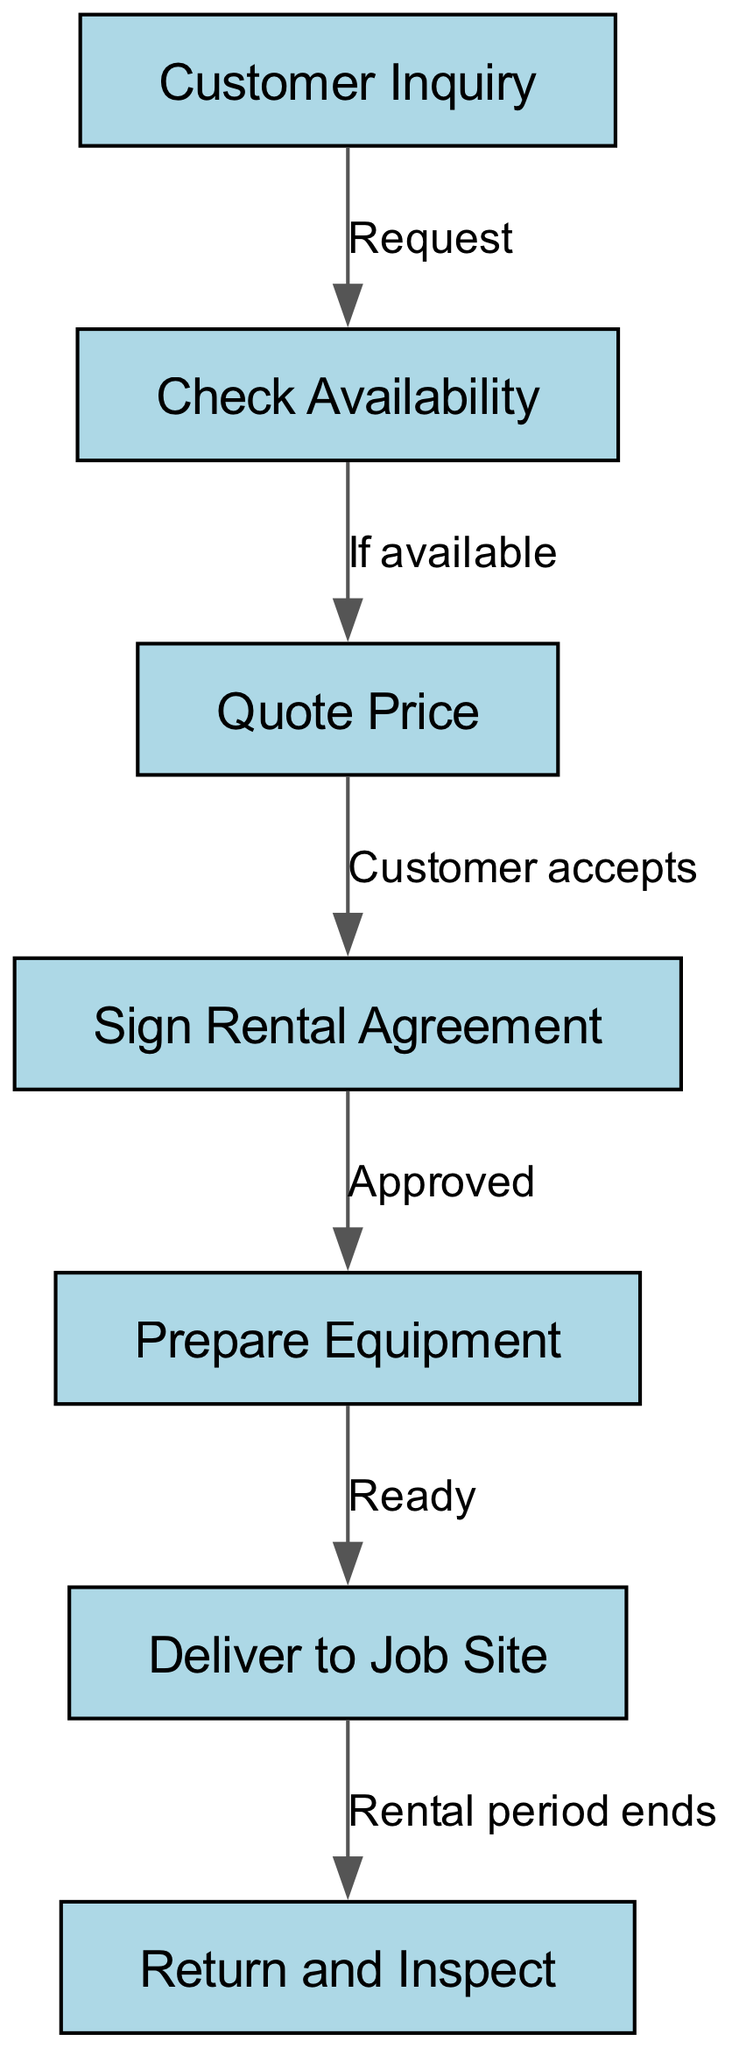What is the first step in the workflow? The diagram starts with the node labeled "Customer Inquiry," which is the first action taken when a customer wants to rent machinery.
Answer: Customer Inquiry How many nodes are in the diagram? The diagram contains a total of 7 distinct nodes, each representing a different step in the rental process.
Answer: 7 What is the connection between 'Check Availability' and 'Quote Price'? The connection shows that if the machinery is available for rent after checking, the next step is to quote the price to the customer.
Answer: If available What happens after the customer signs the rental agreement? Immediately after signing the rental agreement, the next step is to prepare the equipment for the customer’s rental.
Answer: Prepare Equipment What is the last step in the workflow? The last step in the workflow is 'Return and Inspect', which occurs at the end of the rental period.
Answer: Return and Inspect What is required for moving from 'Quote Price' to 'Sign Rental Agreement'? The customer must accept the quote price for the process to move forward towards signing the rental agreement.
Answer: Customer accepts What needs to happen before delivering to the job site? Preparation of the equipment must be completed before delivery can take place.
Answer: Ready Which step comes directly after 'Deliver to Job Site'? The step that follows delivering to the job site is 'Return and Inspect', which indicates the phase of equipment return after the rental period concludes.
Answer: Return and Inspect 